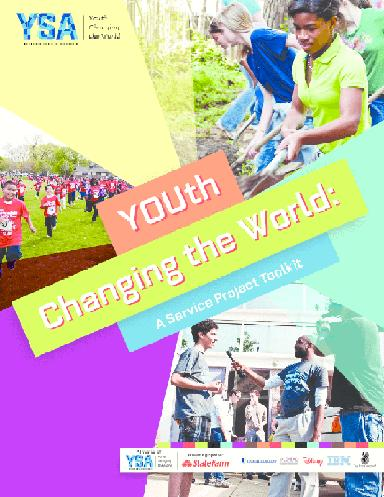What might be an example of a service project featured in the brochure? While the brochure itself is not explicit in the details, an example of a service project could be a community clean-up event organized by young people, where participants gather to remove trash and beautification areas in their neighborhood. Other projects might include tutoring programs, creating community gardens, or fundraising for local charities. 